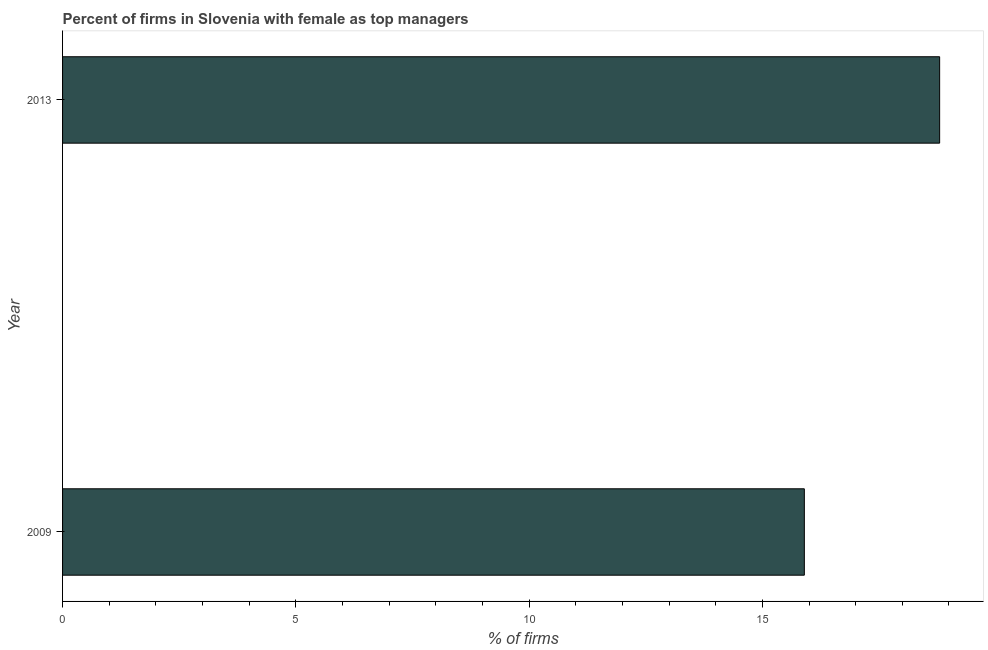What is the title of the graph?
Ensure brevity in your answer.  Percent of firms in Slovenia with female as top managers. What is the label or title of the X-axis?
Give a very brief answer. % of firms. What is the percentage of firms with female as top manager in 2013?
Your answer should be very brief. 18.8. What is the sum of the percentage of firms with female as top manager?
Provide a short and direct response. 34.7. What is the average percentage of firms with female as top manager per year?
Give a very brief answer. 17.35. What is the median percentage of firms with female as top manager?
Your response must be concise. 17.35. In how many years, is the percentage of firms with female as top manager greater than 8 %?
Your response must be concise. 2. Do a majority of the years between 2009 and 2013 (inclusive) have percentage of firms with female as top manager greater than 8 %?
Offer a terse response. Yes. What is the ratio of the percentage of firms with female as top manager in 2009 to that in 2013?
Ensure brevity in your answer.  0.85. Is the percentage of firms with female as top manager in 2009 less than that in 2013?
Keep it short and to the point. Yes. In how many years, is the percentage of firms with female as top manager greater than the average percentage of firms with female as top manager taken over all years?
Provide a short and direct response. 1. Are all the bars in the graph horizontal?
Give a very brief answer. Yes. How many years are there in the graph?
Your response must be concise. 2. What is the difference between two consecutive major ticks on the X-axis?
Your response must be concise. 5. What is the % of firms in 2009?
Make the answer very short. 15.9. What is the % of firms in 2013?
Your answer should be very brief. 18.8. What is the ratio of the % of firms in 2009 to that in 2013?
Your response must be concise. 0.85. 